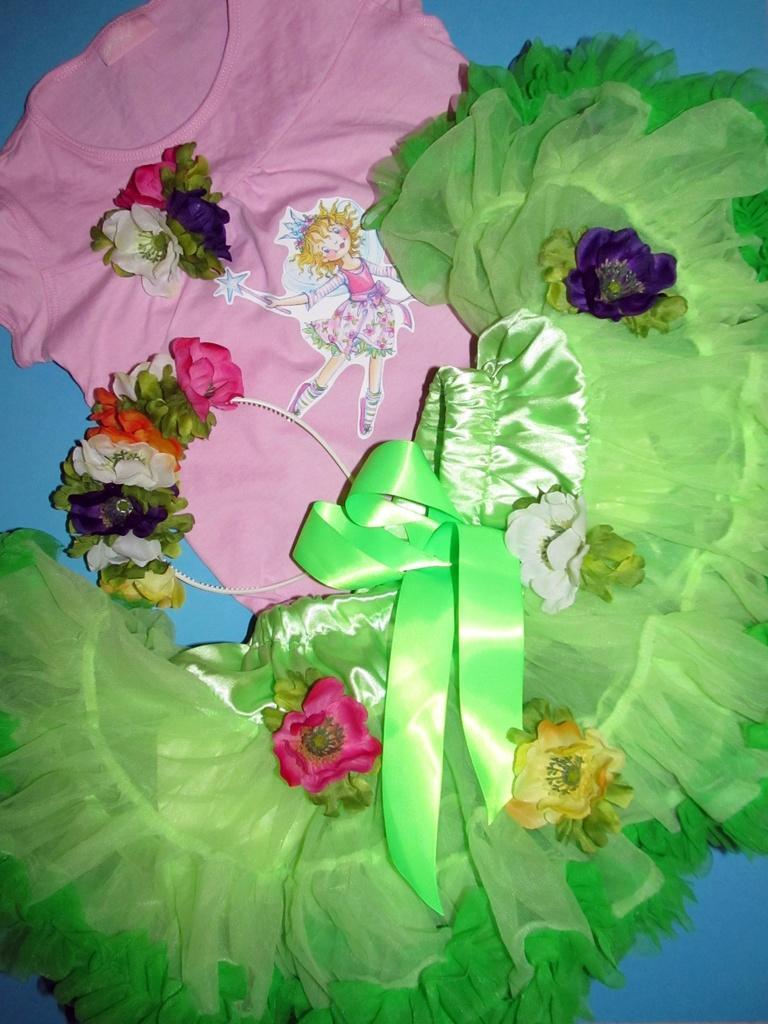Please provide a concise description of this image. In this picture we can see few clothes and a hair band. 